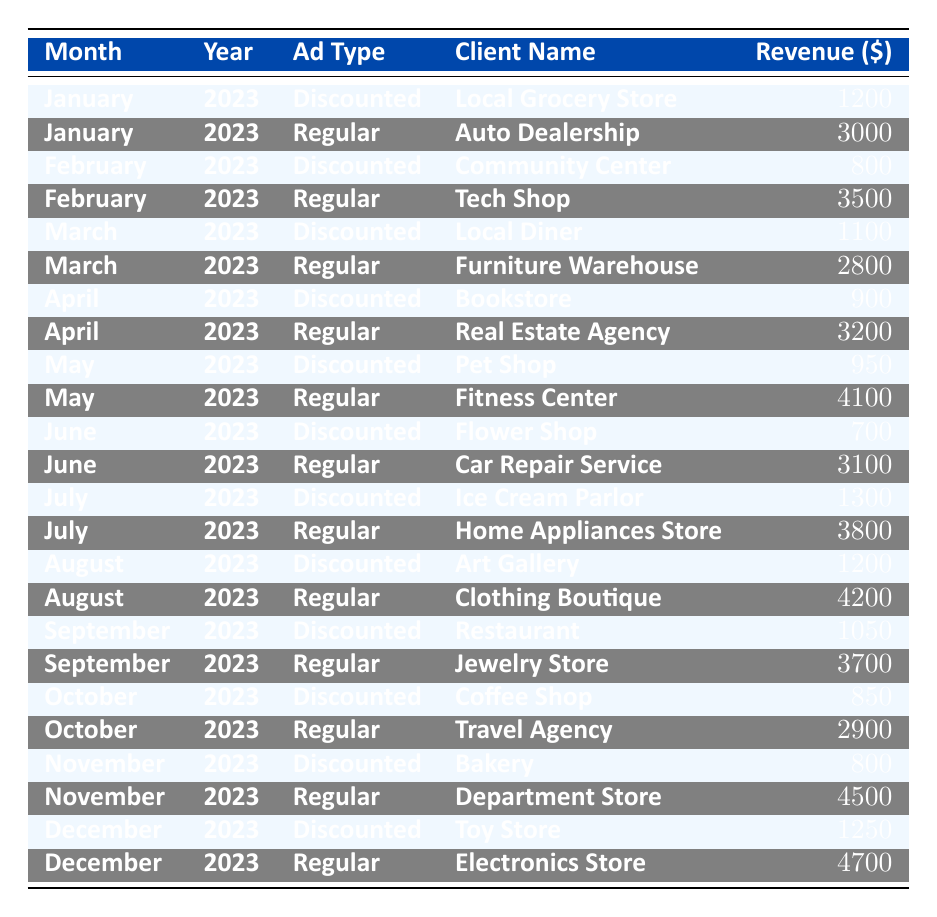What was the total revenue from discounted ads in January 2023? The table shows the revenue from discounted ads in January 2023, which is 1200. It is the only entry for discounted ads in that month.
Answer: 1200 What client paid for a discounted ad in March 2023? In March 2023, the only client for a discounted ad is the Local Diner, with a revenue of 1100.
Answer: Local Diner How much more revenue was generated from regular ads than discounted ads in May 2023? For May 2023, the revenue from regular ads is 4100 and from discounted ads is 950. The difference is calculated as 4100 - 950 = 3150.
Answer: 3150 What is the total revenue from all types of ads in December 2023? The revenue from discounted ads is 1250 and from regular ads is 4700 in December 2023. Summing them gives 1250 + 4700 = 5950.
Answer: 5950 Did the Flower Shop pay more for a discounted ad than the Tech Shop did for a regular ad? The revenue for the Flower Shop (discounted ad) is 700 and for the Tech Shop (regular ad) is 3500. Since 700 is less than 3500, the statement is false.
Answer: No What was the average revenue from discounted ads across all months in 2023? The discounted ad revenues are 1200, 800, 1100, 900, 950, 700, 1300, 1200, 1050, 850, 800, and 1250. Calculating the average involves summing these values (1200 + 800 + 1100 + 900 + 950 + 700 + 1300 + 1200 + 1050 + 850 + 800 + 1250 = 11300) and dividing by the number of months (12) gives 11300 / 12 = 941.67.
Answer: 941.67 Which month in 2023 had the highest revenue for regular ads, and what was that revenue? By comparing the revenues from regular ads across all months, April shows the highest revenue of 3200 for the Real Estate Agency. It is higher than any other month.
Answer: April, 3200 How many total clients made payments for discounted ads throughout 2023? The clients for discounted ads are the Local Grocery Store, Community Center, Local Diner, Bookstore, Pet Shop, Flower Shop, Ice Cream Parlor, Art Gallery, Restaurant, Coffee Shop, Bakery, and Toy Store, which makes a total of 12 unique clients in the table.
Answer: 12 What was the overall revenue from all discounted ads in the second half of 2023 (July to December)? For the second half of 2023, the revenues from discounted ads are 1300, 1200, 1050, 850, 800, and 1250. The total is 1300 + 1200 + 1050 + 850 + 800 + 1250 = 5450.
Answer: 5450 